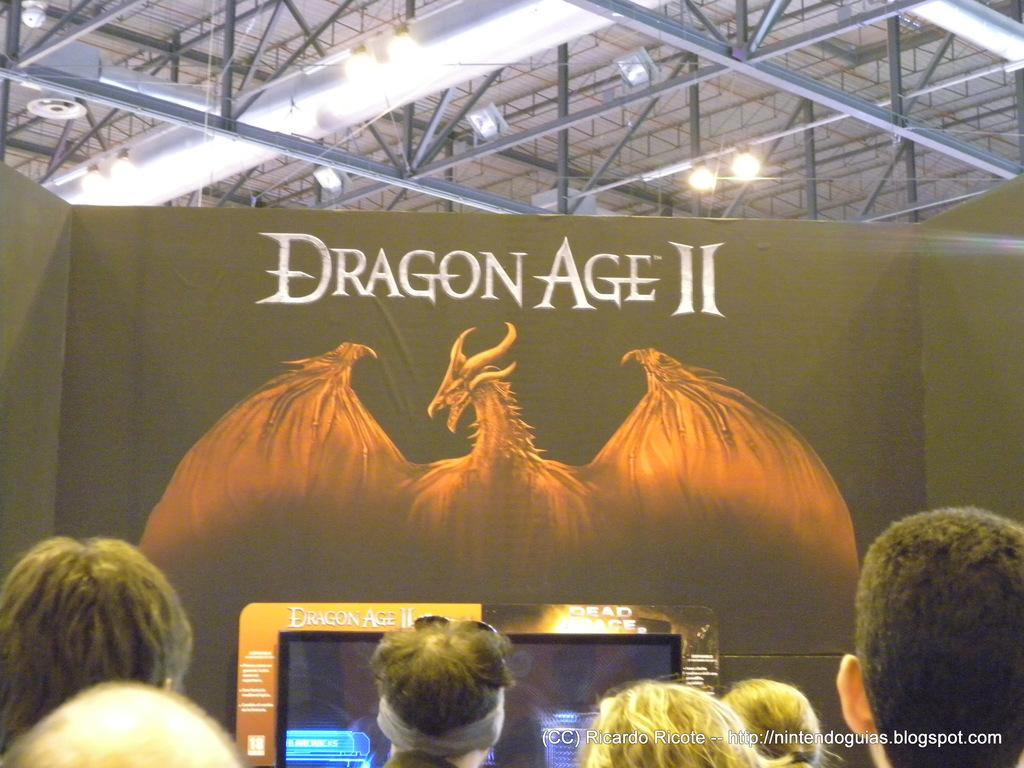How many people are in the image? There is a group of people in the image, but the exact number cannot be determined from the provided facts. What is the purpose of the screen in the image? The purpose of the screen in the image cannot be determined from the provided facts. What is depicted on the poster in the image? The content of the poster in the image cannot be determined from the provided facts. What are the rods and lights in the background of the image used for? The purpose of the rods and lights in the background of the image cannot be determined from the provided facts. What type of grain is being harvested by the cannon in the image? There is no cannon or grain present in the image. 